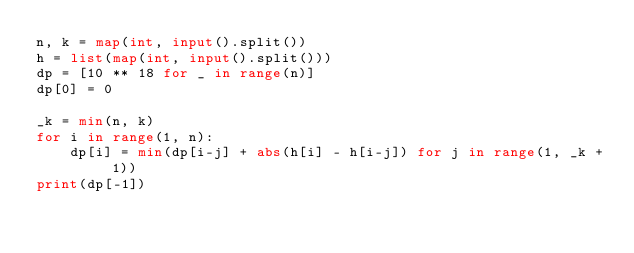<code> <loc_0><loc_0><loc_500><loc_500><_Python_>n, k = map(int, input().split())
h = list(map(int, input().split()))
dp = [10 ** 18 for _ in range(n)]
dp[0] = 0

_k = min(n, k)
for i in range(1, n):
    dp[i] = min(dp[i-j] + abs(h[i] - h[i-j]) for j in range(1, _k + 1))
print(dp[-1])
</code> 